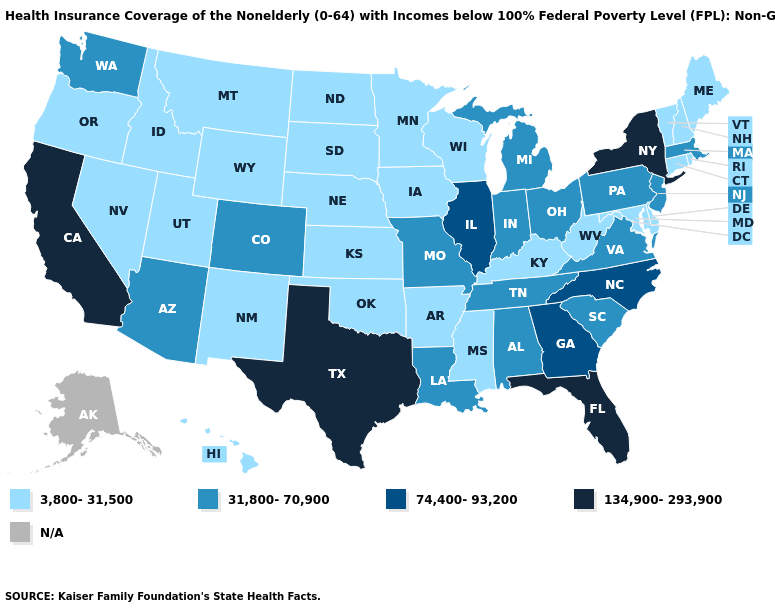What is the highest value in the West ?
Answer briefly. 134,900-293,900. Does the map have missing data?
Write a very short answer. Yes. Which states have the lowest value in the USA?
Answer briefly. Arkansas, Connecticut, Delaware, Hawaii, Idaho, Iowa, Kansas, Kentucky, Maine, Maryland, Minnesota, Mississippi, Montana, Nebraska, Nevada, New Hampshire, New Mexico, North Dakota, Oklahoma, Oregon, Rhode Island, South Dakota, Utah, Vermont, West Virginia, Wisconsin, Wyoming. What is the highest value in the USA?
Short answer required. 134,900-293,900. Is the legend a continuous bar?
Short answer required. No. Name the states that have a value in the range 74,400-93,200?
Give a very brief answer. Georgia, Illinois, North Carolina. Which states have the lowest value in the Northeast?
Write a very short answer. Connecticut, Maine, New Hampshire, Rhode Island, Vermont. How many symbols are there in the legend?
Be succinct. 5. What is the lowest value in the Northeast?
Write a very short answer. 3,800-31,500. Which states hav the highest value in the South?
Answer briefly. Florida, Texas. Which states hav the highest value in the Northeast?
Quick response, please. New York. What is the value of Kentucky?
Write a very short answer. 3,800-31,500. Name the states that have a value in the range N/A?
Concise answer only. Alaska. 